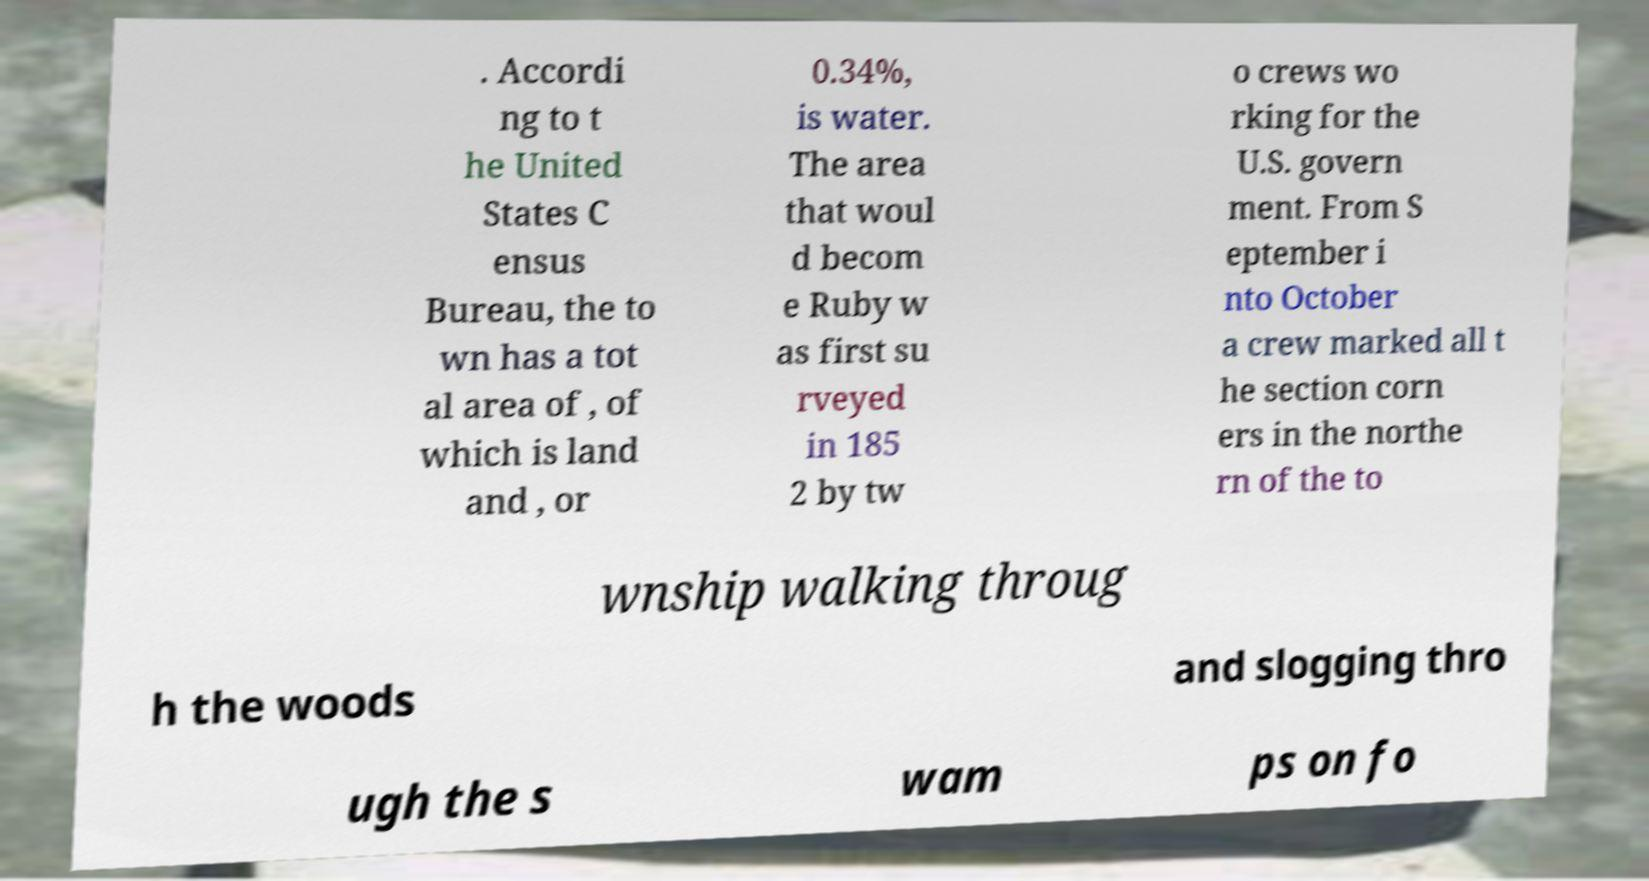I need the written content from this picture converted into text. Can you do that? . Accordi ng to t he United States C ensus Bureau, the to wn has a tot al area of , of which is land and , or 0.34%, is water. The area that woul d becom e Ruby w as first su rveyed in 185 2 by tw o crews wo rking for the U.S. govern ment. From S eptember i nto October a crew marked all t he section corn ers in the northe rn of the to wnship walking throug h the woods and slogging thro ugh the s wam ps on fo 